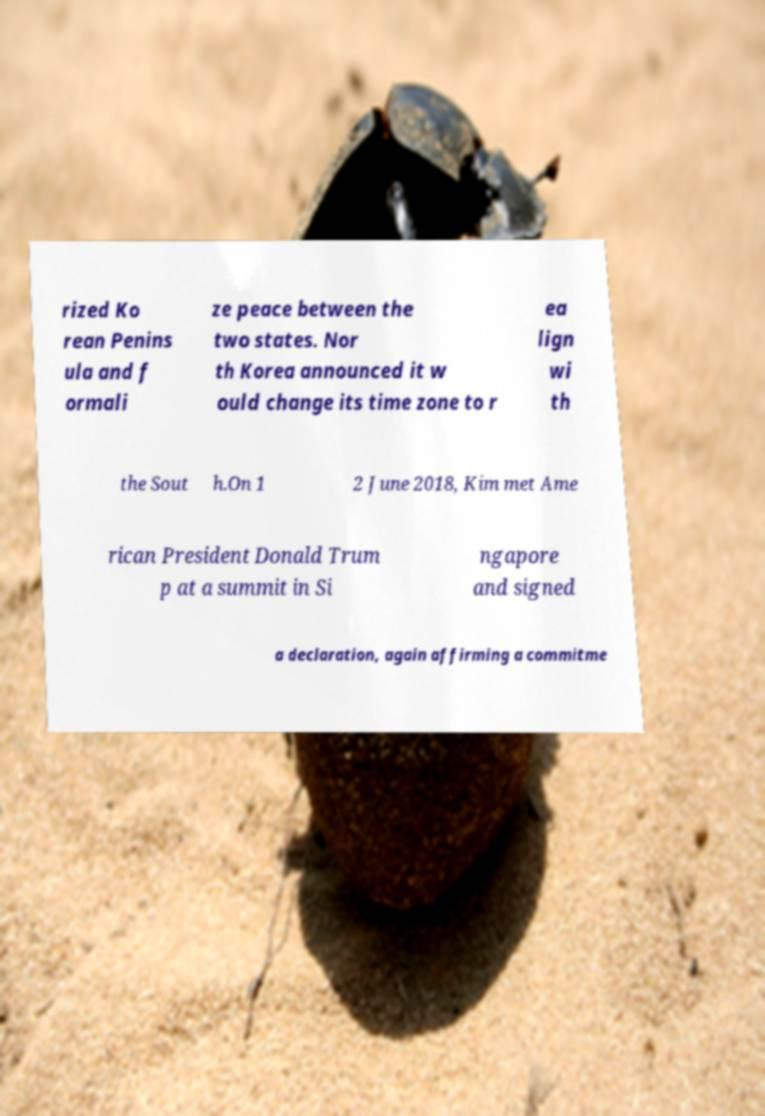Please read and relay the text visible in this image. What does it say? rized Ko rean Penins ula and f ormali ze peace between the two states. Nor th Korea announced it w ould change its time zone to r ea lign wi th the Sout h.On 1 2 June 2018, Kim met Ame rican President Donald Trum p at a summit in Si ngapore and signed a declaration, again affirming a commitme 